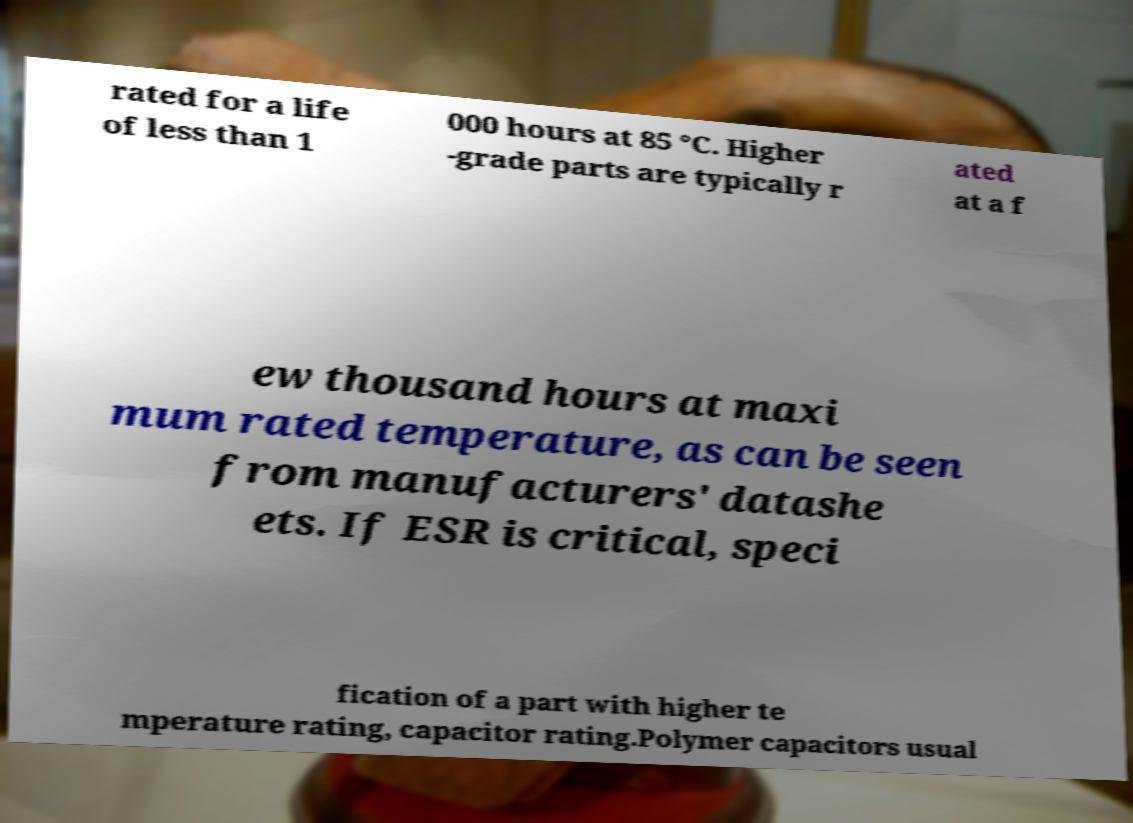For documentation purposes, I need the text within this image transcribed. Could you provide that? rated for a life of less than 1 000 hours at 85 °C. Higher -grade parts are typically r ated at a f ew thousand hours at maxi mum rated temperature, as can be seen from manufacturers' datashe ets. If ESR is critical, speci fication of a part with higher te mperature rating, capacitor rating.Polymer capacitors usual 